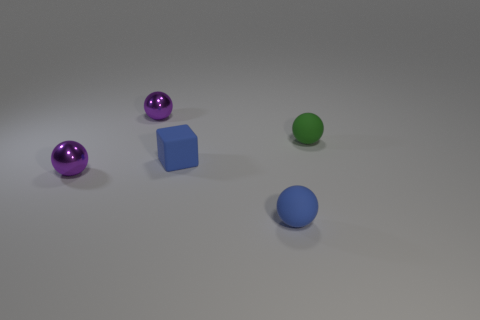Which object in this image is the tallest? The tallest object in the image is the green sphere; it stands out by its height in comparison to the other objects. 